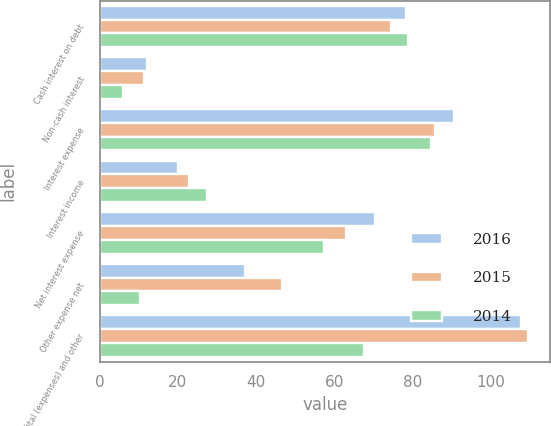Convert chart to OTSL. <chart><loc_0><loc_0><loc_500><loc_500><stacked_bar_chart><ecel><fcel>Cash interest on debt<fcel>Non-cash interest<fcel>Interest expense<fcel>Interest income<fcel>Net interest expense<fcel>Other expense net<fcel>Total (expenses) and other<nl><fcel>2016<fcel>78.4<fcel>12.2<fcel>90.6<fcel>20.1<fcel>70.5<fcel>37.3<fcel>107.8<nl><fcel>2015<fcel>74.6<fcel>11.2<fcel>85.8<fcel>22.8<fcel>63<fcel>46.7<fcel>109.7<nl><fcel>2014<fcel>78.9<fcel>6<fcel>84.9<fcel>27.4<fcel>57.5<fcel>10.2<fcel>67.7<nl></chart> 